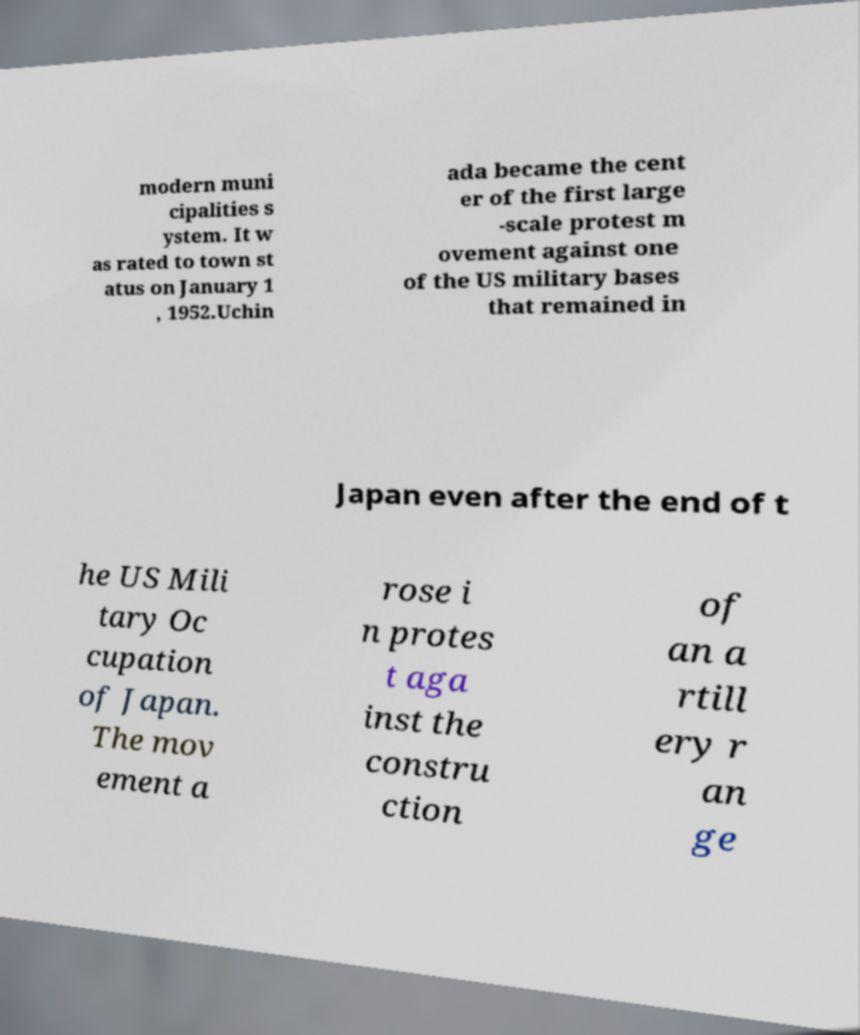I need the written content from this picture converted into text. Can you do that? modern muni cipalities s ystem. It w as rated to town st atus on January 1 , 1952.Uchin ada became the cent er of the first large -scale protest m ovement against one of the US military bases that remained in Japan even after the end of t he US Mili tary Oc cupation of Japan. The mov ement a rose i n protes t aga inst the constru ction of an a rtill ery r an ge 